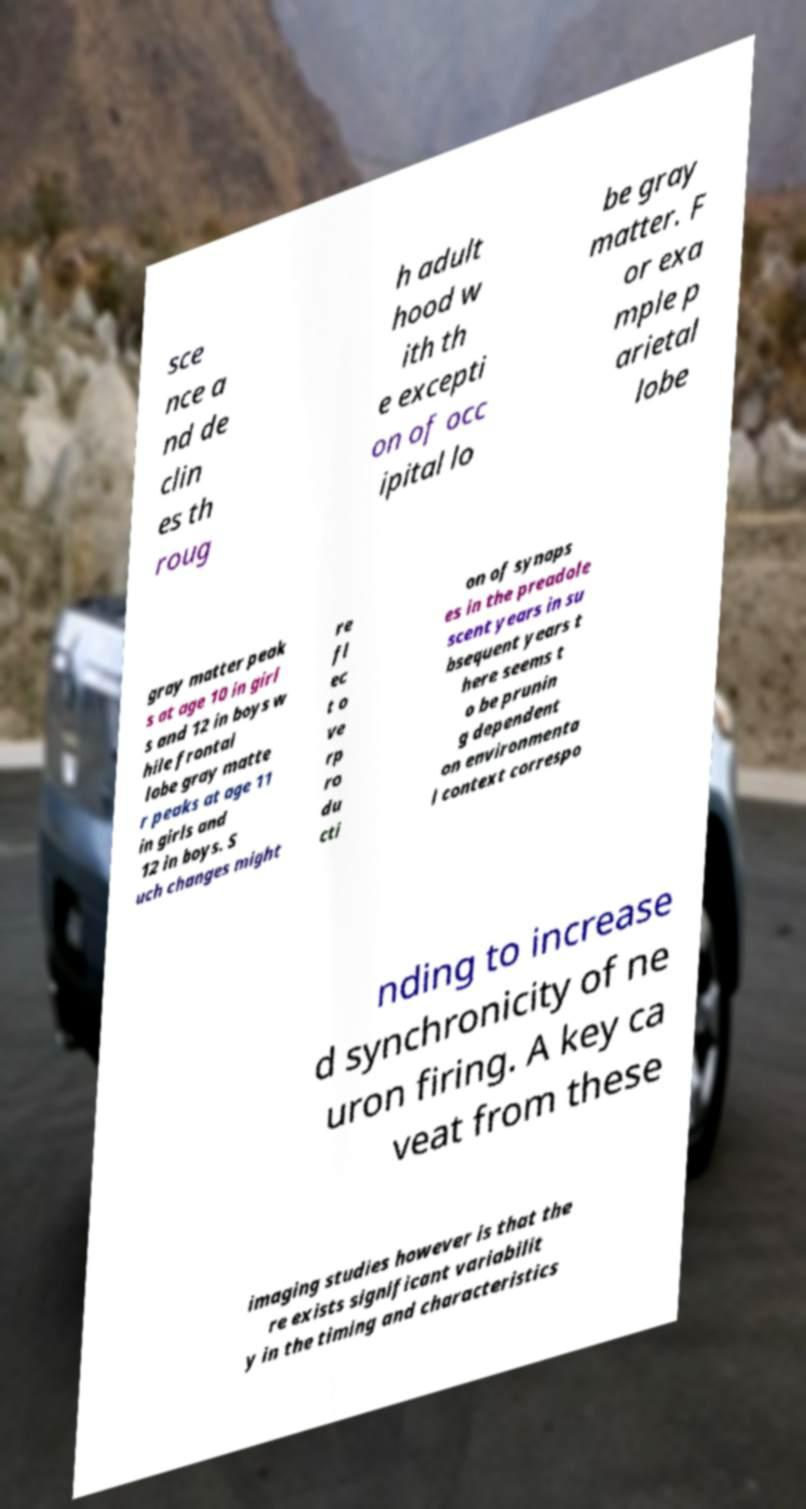Can you accurately transcribe the text from the provided image for me? sce nce a nd de clin es th roug h adult hood w ith th e excepti on of occ ipital lo be gray matter. F or exa mple p arietal lobe gray matter peak s at age 10 in girl s and 12 in boys w hile frontal lobe gray matte r peaks at age 11 in girls and 12 in boys. S uch changes might re fl ec t o ve rp ro du cti on of synaps es in the preadole scent years in su bsequent years t here seems t o be prunin g dependent on environmenta l context correspo nding to increase d synchronicity of ne uron firing. A key ca veat from these imaging studies however is that the re exists significant variabilit y in the timing and characteristics 